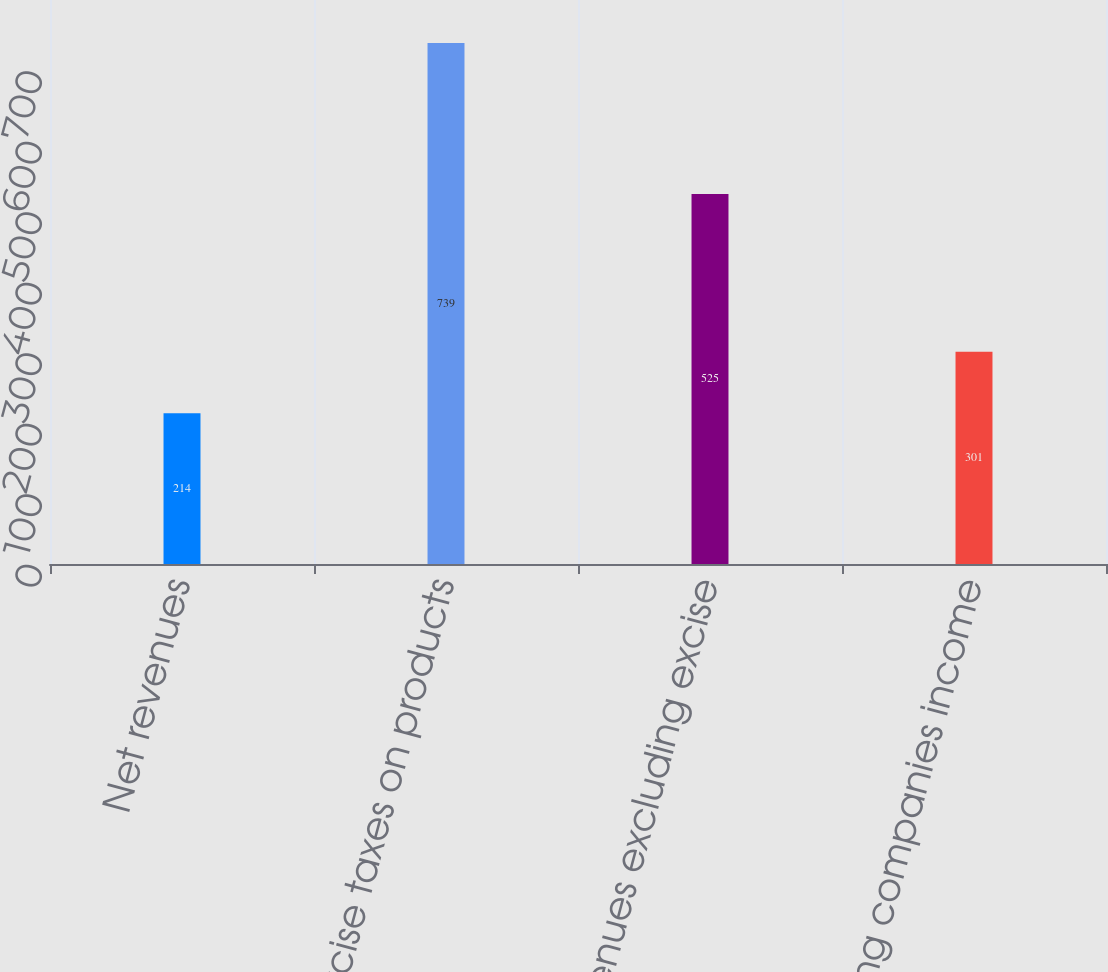<chart> <loc_0><loc_0><loc_500><loc_500><bar_chart><fcel>Net revenues<fcel>Excise taxes on products<fcel>Net revenues excluding excise<fcel>Operating companies income<nl><fcel>214<fcel>739<fcel>525<fcel>301<nl></chart> 